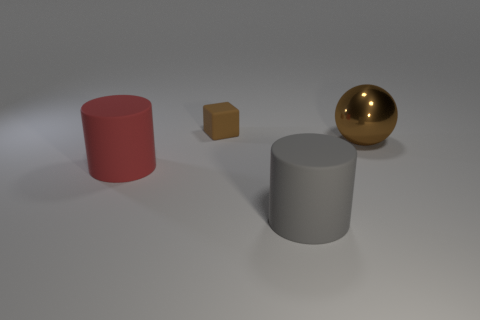Do the small rubber thing and the big red object have the same shape?
Offer a very short reply. No. What color is the large rubber object behind the rubber cylinder to the right of the red matte cylinder left of the tiny brown thing?
Keep it short and to the point. Red. How many red things have the same shape as the gray object?
Make the answer very short. 1. What size is the brown object behind the thing on the right side of the large gray rubber cylinder?
Give a very brief answer. Small. Do the ball and the red rubber cylinder have the same size?
Your answer should be very brief. Yes. There is a rubber cylinder that is to the left of the thing that is behind the ball; are there any red rubber cylinders that are left of it?
Give a very brief answer. No. What size is the red thing?
Keep it short and to the point. Large. What number of other cubes are the same size as the matte block?
Provide a short and direct response. 0. There is a gray thing that is the same shape as the large red matte object; what material is it?
Your response must be concise. Rubber. There is a thing that is both in front of the tiny object and to the left of the big gray rubber object; what is its shape?
Give a very brief answer. Cylinder. 